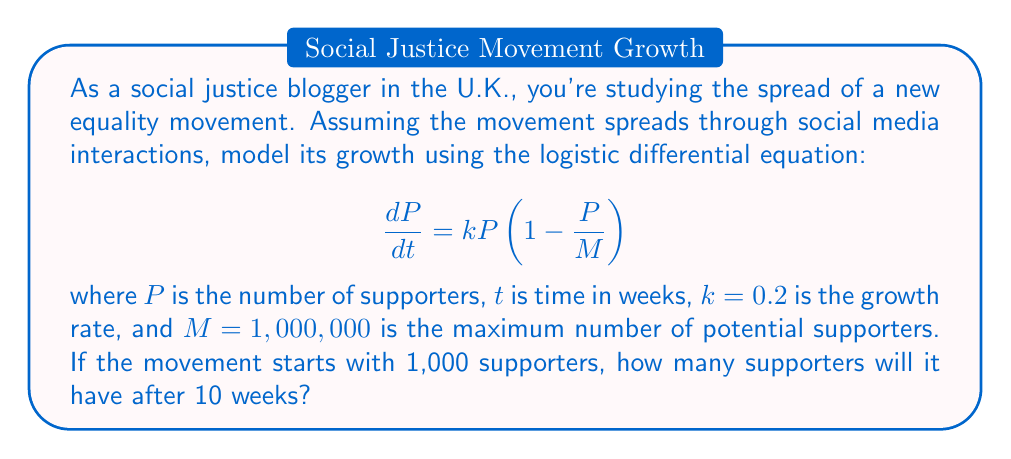Teach me how to tackle this problem. To solve this problem, we need to use the solution to the logistic differential equation:

1) The general solution to the logistic equation is:

   $$P(t) = \frac{M}{1 + (\frac{M}{P_0} - 1)e^{-kt}}$$

   where $P_0$ is the initial population.

2) We're given:
   $M = 1,000,000$
   $k = 0.2$
   $P_0 = 1,000$
   $t = 10$ weeks

3) Let's substitute these values into the equation:

   $$P(10) = \frac{1,000,000}{1 + (\frac{1,000,000}{1,000} - 1)e^{-0.2(10)}}$$

4) Simplify:
   $$P(10) = \frac{1,000,000}{1 + (999)e^{-2}}$$

5) Calculate $e^{-2} \approx 0.1353$

6) Substitute:
   $$P(10) = \frac{1,000,000}{1 + (999)(0.1353)}$$

7) Evaluate:
   $$P(10) = \frac{1,000,000}{136.1647} \approx 7,344$$

8) Round to the nearest whole number:
   $$P(10) \approx 7,344$$ supporters after 10 weeks.
Answer: 7,344 supporters 